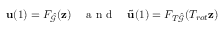<formula> <loc_0><loc_0><loc_500><loc_500>u ( 1 ) = F _ { \hat { \mathcal { G } } } ( z ) \quad a n d \quad \tilde { u } ( 1 ) = F _ { T \hat { \mathcal { G } } } ( T _ { r o t } z )</formula> 